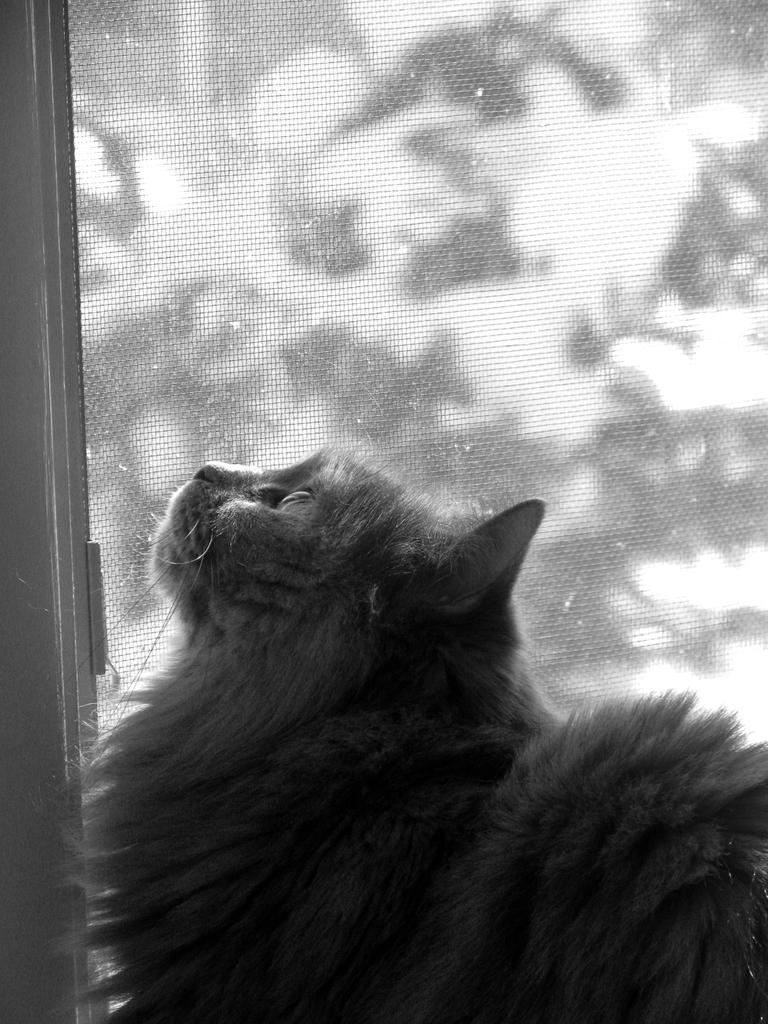What is the color scheme of the image? The image is black and white. What type of living creature can be seen in the image? There is an animal in the image. What structure is visible in the background of the image? There appears to be a door in the background of the image. What type of bead is being used to create the animal's fur in the image? There is no bead present in the image, and the animal's fur is not created using beads. 